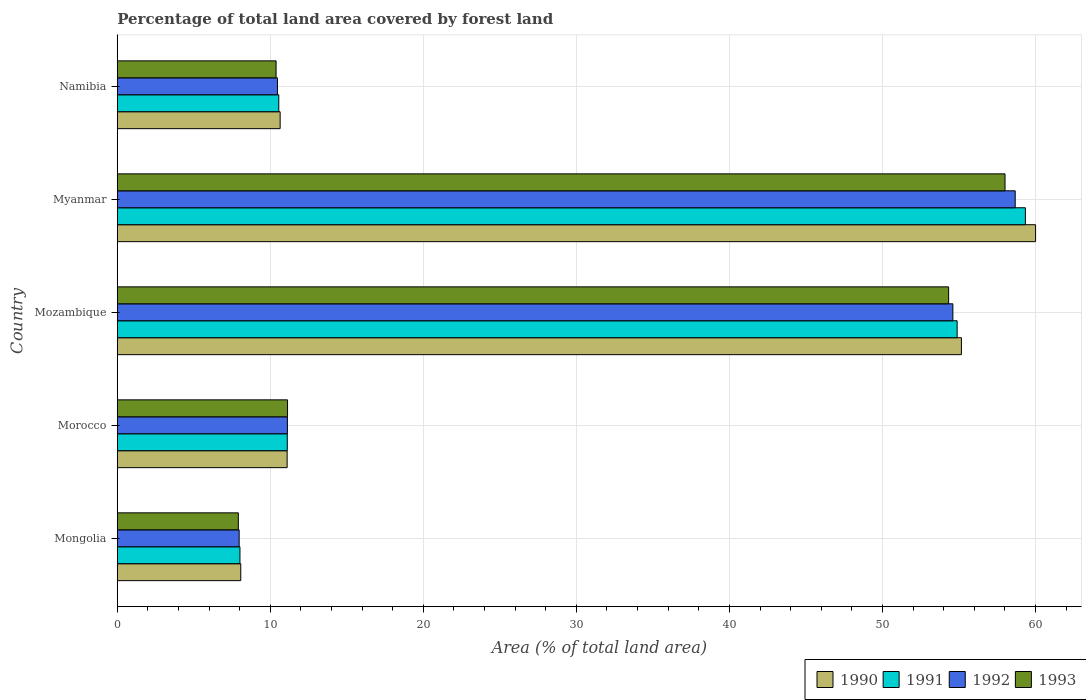How many groups of bars are there?
Ensure brevity in your answer.  5. How many bars are there on the 1st tick from the bottom?
Keep it short and to the point. 4. What is the label of the 2nd group of bars from the top?
Your answer should be compact. Myanmar. What is the percentage of forest land in 1991 in Mozambique?
Offer a very short reply. 54.88. Across all countries, what is the maximum percentage of forest land in 1993?
Keep it short and to the point. 58.01. Across all countries, what is the minimum percentage of forest land in 1993?
Offer a very short reply. 7.91. In which country was the percentage of forest land in 1992 maximum?
Ensure brevity in your answer.  Myanmar. In which country was the percentage of forest land in 1991 minimum?
Provide a short and direct response. Mongolia. What is the total percentage of forest land in 1993 in the graph?
Your answer should be compact. 141.75. What is the difference between the percentage of forest land in 1993 in Morocco and that in Mozambique?
Give a very brief answer. -43.2. What is the difference between the percentage of forest land in 1992 in Morocco and the percentage of forest land in 1991 in Myanmar?
Your answer should be very brief. -48.23. What is the average percentage of forest land in 1990 per country?
Make the answer very short. 29. What is the difference between the percentage of forest land in 1992 and percentage of forest land in 1991 in Mozambique?
Make the answer very short. -0.28. In how many countries, is the percentage of forest land in 1993 greater than 56 %?
Keep it short and to the point. 1. What is the ratio of the percentage of forest land in 1992 in Morocco to that in Myanmar?
Your response must be concise. 0.19. Is the difference between the percentage of forest land in 1992 in Morocco and Myanmar greater than the difference between the percentage of forest land in 1991 in Morocco and Myanmar?
Keep it short and to the point. Yes. What is the difference between the highest and the second highest percentage of forest land in 1990?
Your answer should be very brief. 4.85. What is the difference between the highest and the lowest percentage of forest land in 1993?
Keep it short and to the point. 50.1. Is it the case that in every country, the sum of the percentage of forest land in 1993 and percentage of forest land in 1990 is greater than the sum of percentage of forest land in 1991 and percentage of forest land in 1992?
Offer a very short reply. No. What does the 4th bar from the top in Mongolia represents?
Give a very brief answer. 1990. Are all the bars in the graph horizontal?
Make the answer very short. Yes. Where does the legend appear in the graph?
Your answer should be compact. Bottom right. How many legend labels are there?
Offer a very short reply. 4. What is the title of the graph?
Provide a short and direct response. Percentage of total land area covered by forest land. What is the label or title of the X-axis?
Your response must be concise. Area (% of total land area). What is the Area (% of total land area) of 1990 in Mongolia?
Make the answer very short. 8.07. What is the Area (% of total land area) in 1991 in Mongolia?
Provide a short and direct response. 8.02. What is the Area (% of total land area) in 1992 in Mongolia?
Offer a very short reply. 7.96. What is the Area (% of total land area) of 1993 in Mongolia?
Offer a terse response. 7.91. What is the Area (% of total land area) in 1990 in Morocco?
Your response must be concise. 11.1. What is the Area (% of total land area) of 1991 in Morocco?
Your answer should be very brief. 11.11. What is the Area (% of total land area) of 1992 in Morocco?
Provide a succinct answer. 11.12. What is the Area (% of total land area) of 1993 in Morocco?
Offer a very short reply. 11.13. What is the Area (% of total land area) in 1990 in Mozambique?
Your answer should be very brief. 55.16. What is the Area (% of total land area) of 1991 in Mozambique?
Keep it short and to the point. 54.88. What is the Area (% of total land area) in 1992 in Mozambique?
Keep it short and to the point. 54.6. What is the Area (% of total land area) in 1993 in Mozambique?
Ensure brevity in your answer.  54.33. What is the Area (% of total land area) of 1990 in Myanmar?
Ensure brevity in your answer.  60.01. What is the Area (% of total land area) of 1991 in Myanmar?
Your answer should be compact. 59.34. What is the Area (% of total land area) in 1992 in Myanmar?
Give a very brief answer. 58.68. What is the Area (% of total land area) in 1993 in Myanmar?
Offer a terse response. 58.01. What is the Area (% of total land area) in 1990 in Namibia?
Offer a terse response. 10.64. What is the Area (% of total land area) of 1991 in Namibia?
Give a very brief answer. 10.55. What is the Area (% of total land area) in 1992 in Namibia?
Keep it short and to the point. 10.47. What is the Area (% of total land area) of 1993 in Namibia?
Ensure brevity in your answer.  10.38. Across all countries, what is the maximum Area (% of total land area) of 1990?
Provide a succinct answer. 60.01. Across all countries, what is the maximum Area (% of total land area) of 1991?
Keep it short and to the point. 59.34. Across all countries, what is the maximum Area (% of total land area) of 1992?
Keep it short and to the point. 58.68. Across all countries, what is the maximum Area (% of total land area) of 1993?
Offer a very short reply. 58.01. Across all countries, what is the minimum Area (% of total land area) of 1990?
Offer a very short reply. 8.07. Across all countries, what is the minimum Area (% of total land area) of 1991?
Ensure brevity in your answer.  8.02. Across all countries, what is the minimum Area (% of total land area) in 1992?
Your answer should be very brief. 7.96. Across all countries, what is the minimum Area (% of total land area) in 1993?
Offer a terse response. 7.91. What is the total Area (% of total land area) of 1990 in the graph?
Offer a very short reply. 144.98. What is the total Area (% of total land area) of 1991 in the graph?
Keep it short and to the point. 143.91. What is the total Area (% of total land area) in 1992 in the graph?
Ensure brevity in your answer.  142.83. What is the total Area (% of total land area) in 1993 in the graph?
Make the answer very short. 141.75. What is the difference between the Area (% of total land area) of 1990 in Mongolia and that in Morocco?
Ensure brevity in your answer.  -3.03. What is the difference between the Area (% of total land area) in 1991 in Mongolia and that in Morocco?
Ensure brevity in your answer.  -3.09. What is the difference between the Area (% of total land area) in 1992 in Mongolia and that in Morocco?
Give a very brief answer. -3.15. What is the difference between the Area (% of total land area) in 1993 in Mongolia and that in Morocco?
Your answer should be very brief. -3.22. What is the difference between the Area (% of total land area) in 1990 in Mongolia and that in Mozambique?
Offer a very short reply. -47.09. What is the difference between the Area (% of total land area) of 1991 in Mongolia and that in Mozambique?
Offer a very short reply. -46.87. What is the difference between the Area (% of total land area) of 1992 in Mongolia and that in Mozambique?
Provide a short and direct response. -46.64. What is the difference between the Area (% of total land area) in 1993 in Mongolia and that in Mozambique?
Offer a very short reply. -46.42. What is the difference between the Area (% of total land area) in 1990 in Mongolia and that in Myanmar?
Offer a very short reply. -51.94. What is the difference between the Area (% of total land area) in 1991 in Mongolia and that in Myanmar?
Your response must be concise. -51.33. What is the difference between the Area (% of total land area) in 1992 in Mongolia and that in Myanmar?
Make the answer very short. -50.71. What is the difference between the Area (% of total land area) of 1993 in Mongolia and that in Myanmar?
Make the answer very short. -50.1. What is the difference between the Area (% of total land area) of 1990 in Mongolia and that in Namibia?
Provide a succinct answer. -2.57. What is the difference between the Area (% of total land area) of 1991 in Mongolia and that in Namibia?
Offer a terse response. -2.54. What is the difference between the Area (% of total land area) in 1992 in Mongolia and that in Namibia?
Ensure brevity in your answer.  -2.5. What is the difference between the Area (% of total land area) of 1993 in Mongolia and that in Namibia?
Your answer should be compact. -2.47. What is the difference between the Area (% of total land area) in 1990 in Morocco and that in Mozambique?
Give a very brief answer. -44.06. What is the difference between the Area (% of total land area) in 1991 in Morocco and that in Mozambique?
Ensure brevity in your answer.  -43.77. What is the difference between the Area (% of total land area) of 1992 in Morocco and that in Mozambique?
Offer a terse response. -43.49. What is the difference between the Area (% of total land area) of 1993 in Morocco and that in Mozambique?
Your response must be concise. -43.2. What is the difference between the Area (% of total land area) in 1990 in Morocco and that in Myanmar?
Offer a very short reply. -48.91. What is the difference between the Area (% of total land area) of 1991 in Morocco and that in Myanmar?
Your answer should be very brief. -48.23. What is the difference between the Area (% of total land area) in 1992 in Morocco and that in Myanmar?
Your answer should be very brief. -47.56. What is the difference between the Area (% of total land area) of 1993 in Morocco and that in Myanmar?
Ensure brevity in your answer.  -46.89. What is the difference between the Area (% of total land area) in 1990 in Morocco and that in Namibia?
Your answer should be very brief. 0.46. What is the difference between the Area (% of total land area) of 1991 in Morocco and that in Namibia?
Ensure brevity in your answer.  0.55. What is the difference between the Area (% of total land area) in 1992 in Morocco and that in Namibia?
Make the answer very short. 0.65. What is the difference between the Area (% of total land area) of 1993 in Morocco and that in Namibia?
Make the answer very short. 0.75. What is the difference between the Area (% of total land area) in 1990 in Mozambique and that in Myanmar?
Your answer should be compact. -4.85. What is the difference between the Area (% of total land area) in 1991 in Mozambique and that in Myanmar?
Give a very brief answer. -4.46. What is the difference between the Area (% of total land area) of 1992 in Mozambique and that in Myanmar?
Keep it short and to the point. -4.07. What is the difference between the Area (% of total land area) of 1993 in Mozambique and that in Myanmar?
Ensure brevity in your answer.  -3.69. What is the difference between the Area (% of total land area) in 1990 in Mozambique and that in Namibia?
Your answer should be very brief. 44.52. What is the difference between the Area (% of total land area) in 1991 in Mozambique and that in Namibia?
Make the answer very short. 44.33. What is the difference between the Area (% of total land area) of 1992 in Mozambique and that in Namibia?
Your response must be concise. 44.14. What is the difference between the Area (% of total land area) of 1993 in Mozambique and that in Namibia?
Offer a very short reply. 43.95. What is the difference between the Area (% of total land area) in 1990 in Myanmar and that in Namibia?
Provide a short and direct response. 49.37. What is the difference between the Area (% of total land area) of 1991 in Myanmar and that in Namibia?
Offer a terse response. 48.79. What is the difference between the Area (% of total land area) in 1992 in Myanmar and that in Namibia?
Offer a terse response. 48.21. What is the difference between the Area (% of total land area) of 1993 in Myanmar and that in Namibia?
Offer a terse response. 47.64. What is the difference between the Area (% of total land area) in 1990 in Mongolia and the Area (% of total land area) in 1991 in Morocco?
Your answer should be compact. -3.04. What is the difference between the Area (% of total land area) in 1990 in Mongolia and the Area (% of total land area) in 1992 in Morocco?
Your answer should be compact. -3.05. What is the difference between the Area (% of total land area) in 1990 in Mongolia and the Area (% of total land area) in 1993 in Morocco?
Offer a terse response. -3.06. What is the difference between the Area (% of total land area) of 1991 in Mongolia and the Area (% of total land area) of 1992 in Morocco?
Offer a terse response. -3.1. What is the difference between the Area (% of total land area) in 1991 in Mongolia and the Area (% of total land area) in 1993 in Morocco?
Your response must be concise. -3.11. What is the difference between the Area (% of total land area) of 1992 in Mongolia and the Area (% of total land area) of 1993 in Morocco?
Your response must be concise. -3.16. What is the difference between the Area (% of total land area) in 1990 in Mongolia and the Area (% of total land area) in 1991 in Mozambique?
Make the answer very short. -46.81. What is the difference between the Area (% of total land area) in 1990 in Mongolia and the Area (% of total land area) in 1992 in Mozambique?
Your answer should be compact. -46.54. What is the difference between the Area (% of total land area) of 1990 in Mongolia and the Area (% of total land area) of 1993 in Mozambique?
Ensure brevity in your answer.  -46.26. What is the difference between the Area (% of total land area) of 1991 in Mongolia and the Area (% of total land area) of 1992 in Mozambique?
Offer a terse response. -46.59. What is the difference between the Area (% of total land area) of 1991 in Mongolia and the Area (% of total land area) of 1993 in Mozambique?
Your response must be concise. -46.31. What is the difference between the Area (% of total land area) of 1992 in Mongolia and the Area (% of total land area) of 1993 in Mozambique?
Give a very brief answer. -46.36. What is the difference between the Area (% of total land area) in 1990 in Mongolia and the Area (% of total land area) in 1991 in Myanmar?
Ensure brevity in your answer.  -51.27. What is the difference between the Area (% of total land area) of 1990 in Mongolia and the Area (% of total land area) of 1992 in Myanmar?
Offer a terse response. -50.61. What is the difference between the Area (% of total land area) of 1990 in Mongolia and the Area (% of total land area) of 1993 in Myanmar?
Your answer should be compact. -49.94. What is the difference between the Area (% of total land area) of 1991 in Mongolia and the Area (% of total land area) of 1992 in Myanmar?
Give a very brief answer. -50.66. What is the difference between the Area (% of total land area) of 1991 in Mongolia and the Area (% of total land area) of 1993 in Myanmar?
Your response must be concise. -50. What is the difference between the Area (% of total land area) in 1992 in Mongolia and the Area (% of total land area) in 1993 in Myanmar?
Give a very brief answer. -50.05. What is the difference between the Area (% of total land area) of 1990 in Mongolia and the Area (% of total land area) of 1991 in Namibia?
Ensure brevity in your answer.  -2.48. What is the difference between the Area (% of total land area) of 1990 in Mongolia and the Area (% of total land area) of 1992 in Namibia?
Your response must be concise. -2.4. What is the difference between the Area (% of total land area) of 1990 in Mongolia and the Area (% of total land area) of 1993 in Namibia?
Give a very brief answer. -2.31. What is the difference between the Area (% of total land area) of 1991 in Mongolia and the Area (% of total land area) of 1992 in Namibia?
Give a very brief answer. -2.45. What is the difference between the Area (% of total land area) of 1991 in Mongolia and the Area (% of total land area) of 1993 in Namibia?
Offer a very short reply. -2.36. What is the difference between the Area (% of total land area) in 1992 in Mongolia and the Area (% of total land area) in 1993 in Namibia?
Your response must be concise. -2.41. What is the difference between the Area (% of total land area) in 1990 in Morocco and the Area (% of total land area) in 1991 in Mozambique?
Make the answer very short. -43.78. What is the difference between the Area (% of total land area) in 1990 in Morocco and the Area (% of total land area) in 1992 in Mozambique?
Provide a short and direct response. -43.5. What is the difference between the Area (% of total land area) in 1990 in Morocco and the Area (% of total land area) in 1993 in Mozambique?
Ensure brevity in your answer.  -43.23. What is the difference between the Area (% of total land area) in 1991 in Morocco and the Area (% of total land area) in 1992 in Mozambique?
Ensure brevity in your answer.  -43.5. What is the difference between the Area (% of total land area) in 1991 in Morocco and the Area (% of total land area) in 1993 in Mozambique?
Provide a succinct answer. -43.22. What is the difference between the Area (% of total land area) of 1992 in Morocco and the Area (% of total land area) of 1993 in Mozambique?
Offer a very short reply. -43.21. What is the difference between the Area (% of total land area) in 1990 in Morocco and the Area (% of total land area) in 1991 in Myanmar?
Keep it short and to the point. -48.24. What is the difference between the Area (% of total land area) of 1990 in Morocco and the Area (% of total land area) of 1992 in Myanmar?
Provide a short and direct response. -47.58. What is the difference between the Area (% of total land area) of 1990 in Morocco and the Area (% of total land area) of 1993 in Myanmar?
Make the answer very short. -46.91. What is the difference between the Area (% of total land area) of 1991 in Morocco and the Area (% of total land area) of 1992 in Myanmar?
Provide a short and direct response. -47.57. What is the difference between the Area (% of total land area) in 1991 in Morocco and the Area (% of total land area) in 1993 in Myanmar?
Keep it short and to the point. -46.9. What is the difference between the Area (% of total land area) in 1992 in Morocco and the Area (% of total land area) in 1993 in Myanmar?
Offer a very short reply. -46.89. What is the difference between the Area (% of total land area) of 1990 in Morocco and the Area (% of total land area) of 1991 in Namibia?
Offer a terse response. 0.55. What is the difference between the Area (% of total land area) in 1990 in Morocco and the Area (% of total land area) in 1992 in Namibia?
Provide a succinct answer. 0.63. What is the difference between the Area (% of total land area) of 1990 in Morocco and the Area (% of total land area) of 1993 in Namibia?
Make the answer very short. 0.72. What is the difference between the Area (% of total land area) of 1991 in Morocco and the Area (% of total land area) of 1992 in Namibia?
Provide a short and direct response. 0.64. What is the difference between the Area (% of total land area) in 1991 in Morocco and the Area (% of total land area) in 1993 in Namibia?
Offer a very short reply. 0.73. What is the difference between the Area (% of total land area) of 1992 in Morocco and the Area (% of total land area) of 1993 in Namibia?
Your answer should be compact. 0.74. What is the difference between the Area (% of total land area) of 1990 in Mozambique and the Area (% of total land area) of 1991 in Myanmar?
Offer a terse response. -4.18. What is the difference between the Area (% of total land area) in 1990 in Mozambique and the Area (% of total land area) in 1992 in Myanmar?
Keep it short and to the point. -3.52. What is the difference between the Area (% of total land area) of 1990 in Mozambique and the Area (% of total land area) of 1993 in Myanmar?
Ensure brevity in your answer.  -2.85. What is the difference between the Area (% of total land area) of 1991 in Mozambique and the Area (% of total land area) of 1992 in Myanmar?
Provide a succinct answer. -3.79. What is the difference between the Area (% of total land area) in 1991 in Mozambique and the Area (% of total land area) in 1993 in Myanmar?
Ensure brevity in your answer.  -3.13. What is the difference between the Area (% of total land area) of 1992 in Mozambique and the Area (% of total land area) of 1993 in Myanmar?
Offer a very short reply. -3.41. What is the difference between the Area (% of total land area) in 1990 in Mozambique and the Area (% of total land area) in 1991 in Namibia?
Ensure brevity in your answer.  44.61. What is the difference between the Area (% of total land area) of 1990 in Mozambique and the Area (% of total land area) of 1992 in Namibia?
Your answer should be very brief. 44.7. What is the difference between the Area (% of total land area) of 1990 in Mozambique and the Area (% of total land area) of 1993 in Namibia?
Keep it short and to the point. 44.78. What is the difference between the Area (% of total land area) of 1991 in Mozambique and the Area (% of total land area) of 1992 in Namibia?
Keep it short and to the point. 44.42. What is the difference between the Area (% of total land area) in 1991 in Mozambique and the Area (% of total land area) in 1993 in Namibia?
Provide a short and direct response. 44.51. What is the difference between the Area (% of total land area) in 1992 in Mozambique and the Area (% of total land area) in 1993 in Namibia?
Your answer should be compact. 44.23. What is the difference between the Area (% of total land area) of 1990 in Myanmar and the Area (% of total land area) of 1991 in Namibia?
Provide a short and direct response. 49.45. What is the difference between the Area (% of total land area) of 1990 in Myanmar and the Area (% of total land area) of 1992 in Namibia?
Your response must be concise. 49.54. What is the difference between the Area (% of total land area) of 1990 in Myanmar and the Area (% of total land area) of 1993 in Namibia?
Provide a short and direct response. 49.63. What is the difference between the Area (% of total land area) of 1991 in Myanmar and the Area (% of total land area) of 1992 in Namibia?
Ensure brevity in your answer.  48.88. What is the difference between the Area (% of total land area) of 1991 in Myanmar and the Area (% of total land area) of 1993 in Namibia?
Your answer should be very brief. 48.97. What is the difference between the Area (% of total land area) of 1992 in Myanmar and the Area (% of total land area) of 1993 in Namibia?
Make the answer very short. 48.3. What is the average Area (% of total land area) in 1990 per country?
Provide a short and direct response. 29. What is the average Area (% of total land area) in 1991 per country?
Give a very brief answer. 28.78. What is the average Area (% of total land area) of 1992 per country?
Keep it short and to the point. 28.57. What is the average Area (% of total land area) of 1993 per country?
Make the answer very short. 28.35. What is the difference between the Area (% of total land area) in 1990 and Area (% of total land area) in 1991 in Mongolia?
Offer a very short reply. 0.05. What is the difference between the Area (% of total land area) of 1990 and Area (% of total land area) of 1992 in Mongolia?
Offer a terse response. 0.11. What is the difference between the Area (% of total land area) in 1990 and Area (% of total land area) in 1993 in Mongolia?
Your answer should be compact. 0.16. What is the difference between the Area (% of total land area) in 1991 and Area (% of total land area) in 1992 in Mongolia?
Your answer should be compact. 0.05. What is the difference between the Area (% of total land area) in 1991 and Area (% of total land area) in 1993 in Mongolia?
Your answer should be compact. 0.11. What is the difference between the Area (% of total land area) of 1992 and Area (% of total land area) of 1993 in Mongolia?
Keep it short and to the point. 0.05. What is the difference between the Area (% of total land area) in 1990 and Area (% of total land area) in 1991 in Morocco?
Provide a succinct answer. -0.01. What is the difference between the Area (% of total land area) of 1990 and Area (% of total land area) of 1992 in Morocco?
Give a very brief answer. -0.02. What is the difference between the Area (% of total land area) in 1990 and Area (% of total land area) in 1993 in Morocco?
Ensure brevity in your answer.  -0.03. What is the difference between the Area (% of total land area) of 1991 and Area (% of total land area) of 1992 in Morocco?
Offer a terse response. -0.01. What is the difference between the Area (% of total land area) of 1991 and Area (% of total land area) of 1993 in Morocco?
Make the answer very short. -0.02. What is the difference between the Area (% of total land area) of 1992 and Area (% of total land area) of 1993 in Morocco?
Provide a short and direct response. -0.01. What is the difference between the Area (% of total land area) of 1990 and Area (% of total land area) of 1991 in Mozambique?
Make the answer very short. 0.28. What is the difference between the Area (% of total land area) of 1990 and Area (% of total land area) of 1992 in Mozambique?
Give a very brief answer. 0.56. What is the difference between the Area (% of total land area) in 1990 and Area (% of total land area) in 1993 in Mozambique?
Provide a succinct answer. 0.84. What is the difference between the Area (% of total land area) of 1991 and Area (% of total land area) of 1992 in Mozambique?
Offer a very short reply. 0.28. What is the difference between the Area (% of total land area) of 1991 and Area (% of total land area) of 1993 in Mozambique?
Keep it short and to the point. 0.56. What is the difference between the Area (% of total land area) in 1992 and Area (% of total land area) in 1993 in Mozambique?
Your answer should be compact. 0.28. What is the difference between the Area (% of total land area) of 1990 and Area (% of total land area) of 1991 in Myanmar?
Give a very brief answer. 0.67. What is the difference between the Area (% of total land area) of 1990 and Area (% of total land area) of 1992 in Myanmar?
Provide a succinct answer. 1.33. What is the difference between the Area (% of total land area) in 1990 and Area (% of total land area) in 1993 in Myanmar?
Your answer should be very brief. 2. What is the difference between the Area (% of total land area) in 1991 and Area (% of total land area) in 1992 in Myanmar?
Ensure brevity in your answer.  0.67. What is the difference between the Area (% of total land area) of 1991 and Area (% of total land area) of 1993 in Myanmar?
Keep it short and to the point. 1.33. What is the difference between the Area (% of total land area) in 1992 and Area (% of total land area) in 1993 in Myanmar?
Provide a short and direct response. 0.67. What is the difference between the Area (% of total land area) of 1990 and Area (% of total land area) of 1991 in Namibia?
Your response must be concise. 0.09. What is the difference between the Area (% of total land area) of 1990 and Area (% of total land area) of 1992 in Namibia?
Provide a succinct answer. 0.18. What is the difference between the Area (% of total land area) in 1990 and Area (% of total land area) in 1993 in Namibia?
Give a very brief answer. 0.27. What is the difference between the Area (% of total land area) of 1991 and Area (% of total land area) of 1992 in Namibia?
Offer a very short reply. 0.09. What is the difference between the Area (% of total land area) of 1991 and Area (% of total land area) of 1993 in Namibia?
Keep it short and to the point. 0.18. What is the difference between the Area (% of total land area) of 1992 and Area (% of total land area) of 1993 in Namibia?
Your response must be concise. 0.09. What is the ratio of the Area (% of total land area) of 1990 in Mongolia to that in Morocco?
Provide a succinct answer. 0.73. What is the ratio of the Area (% of total land area) in 1991 in Mongolia to that in Morocco?
Keep it short and to the point. 0.72. What is the ratio of the Area (% of total land area) of 1992 in Mongolia to that in Morocco?
Your answer should be compact. 0.72. What is the ratio of the Area (% of total land area) in 1993 in Mongolia to that in Morocco?
Offer a very short reply. 0.71. What is the ratio of the Area (% of total land area) of 1990 in Mongolia to that in Mozambique?
Your answer should be very brief. 0.15. What is the ratio of the Area (% of total land area) of 1991 in Mongolia to that in Mozambique?
Make the answer very short. 0.15. What is the ratio of the Area (% of total land area) in 1992 in Mongolia to that in Mozambique?
Ensure brevity in your answer.  0.15. What is the ratio of the Area (% of total land area) in 1993 in Mongolia to that in Mozambique?
Ensure brevity in your answer.  0.15. What is the ratio of the Area (% of total land area) of 1990 in Mongolia to that in Myanmar?
Offer a very short reply. 0.13. What is the ratio of the Area (% of total land area) in 1991 in Mongolia to that in Myanmar?
Your answer should be very brief. 0.14. What is the ratio of the Area (% of total land area) in 1992 in Mongolia to that in Myanmar?
Offer a very short reply. 0.14. What is the ratio of the Area (% of total land area) of 1993 in Mongolia to that in Myanmar?
Your response must be concise. 0.14. What is the ratio of the Area (% of total land area) of 1990 in Mongolia to that in Namibia?
Your response must be concise. 0.76. What is the ratio of the Area (% of total land area) of 1991 in Mongolia to that in Namibia?
Your answer should be very brief. 0.76. What is the ratio of the Area (% of total land area) in 1992 in Mongolia to that in Namibia?
Your answer should be very brief. 0.76. What is the ratio of the Area (% of total land area) of 1993 in Mongolia to that in Namibia?
Provide a succinct answer. 0.76. What is the ratio of the Area (% of total land area) of 1990 in Morocco to that in Mozambique?
Your answer should be compact. 0.2. What is the ratio of the Area (% of total land area) of 1991 in Morocco to that in Mozambique?
Your answer should be compact. 0.2. What is the ratio of the Area (% of total land area) of 1992 in Morocco to that in Mozambique?
Offer a terse response. 0.2. What is the ratio of the Area (% of total land area) of 1993 in Morocco to that in Mozambique?
Ensure brevity in your answer.  0.2. What is the ratio of the Area (% of total land area) in 1990 in Morocco to that in Myanmar?
Offer a very short reply. 0.18. What is the ratio of the Area (% of total land area) in 1991 in Morocco to that in Myanmar?
Your answer should be compact. 0.19. What is the ratio of the Area (% of total land area) of 1992 in Morocco to that in Myanmar?
Provide a succinct answer. 0.19. What is the ratio of the Area (% of total land area) in 1993 in Morocco to that in Myanmar?
Make the answer very short. 0.19. What is the ratio of the Area (% of total land area) in 1990 in Morocco to that in Namibia?
Your response must be concise. 1.04. What is the ratio of the Area (% of total land area) of 1991 in Morocco to that in Namibia?
Offer a terse response. 1.05. What is the ratio of the Area (% of total land area) of 1992 in Morocco to that in Namibia?
Your answer should be very brief. 1.06. What is the ratio of the Area (% of total land area) in 1993 in Morocco to that in Namibia?
Provide a short and direct response. 1.07. What is the ratio of the Area (% of total land area) in 1990 in Mozambique to that in Myanmar?
Your answer should be compact. 0.92. What is the ratio of the Area (% of total land area) in 1991 in Mozambique to that in Myanmar?
Your response must be concise. 0.92. What is the ratio of the Area (% of total land area) of 1992 in Mozambique to that in Myanmar?
Your answer should be compact. 0.93. What is the ratio of the Area (% of total land area) of 1993 in Mozambique to that in Myanmar?
Your answer should be very brief. 0.94. What is the ratio of the Area (% of total land area) of 1990 in Mozambique to that in Namibia?
Provide a succinct answer. 5.18. What is the ratio of the Area (% of total land area) in 1991 in Mozambique to that in Namibia?
Give a very brief answer. 5.2. What is the ratio of the Area (% of total land area) in 1992 in Mozambique to that in Namibia?
Offer a very short reply. 5.22. What is the ratio of the Area (% of total land area) in 1993 in Mozambique to that in Namibia?
Offer a terse response. 5.24. What is the ratio of the Area (% of total land area) of 1990 in Myanmar to that in Namibia?
Offer a terse response. 5.64. What is the ratio of the Area (% of total land area) in 1991 in Myanmar to that in Namibia?
Provide a succinct answer. 5.62. What is the ratio of the Area (% of total land area) in 1992 in Myanmar to that in Namibia?
Provide a short and direct response. 5.61. What is the ratio of the Area (% of total land area) of 1993 in Myanmar to that in Namibia?
Keep it short and to the point. 5.59. What is the difference between the highest and the second highest Area (% of total land area) of 1990?
Provide a succinct answer. 4.85. What is the difference between the highest and the second highest Area (% of total land area) in 1991?
Your answer should be very brief. 4.46. What is the difference between the highest and the second highest Area (% of total land area) of 1992?
Your response must be concise. 4.07. What is the difference between the highest and the second highest Area (% of total land area) of 1993?
Offer a terse response. 3.69. What is the difference between the highest and the lowest Area (% of total land area) in 1990?
Provide a succinct answer. 51.94. What is the difference between the highest and the lowest Area (% of total land area) of 1991?
Your response must be concise. 51.33. What is the difference between the highest and the lowest Area (% of total land area) in 1992?
Your response must be concise. 50.71. What is the difference between the highest and the lowest Area (% of total land area) in 1993?
Your answer should be compact. 50.1. 